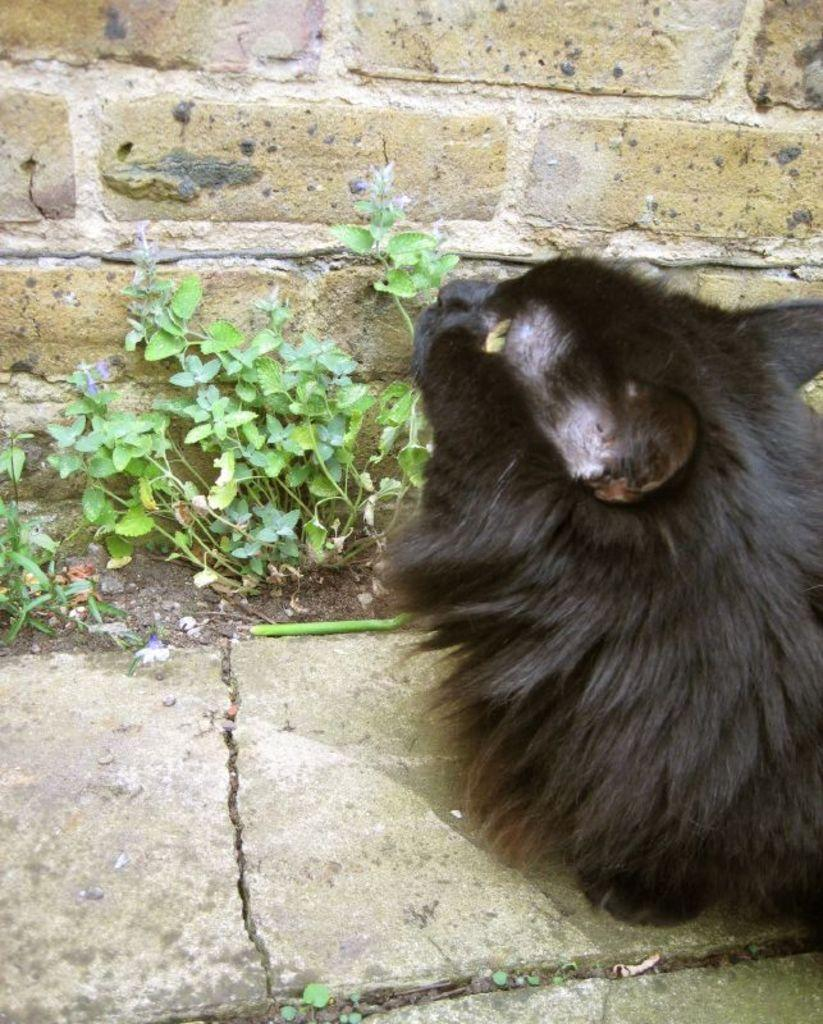What type of creature is present in the image? There is an animal in the image. What color is the animal? The animal is black in color. What is located in front of the animal? There are plants and a wall in front of the animal. What type of cherry is the animal holding in the image? There is no cherry present in the image, and the animal is not holding anything. 